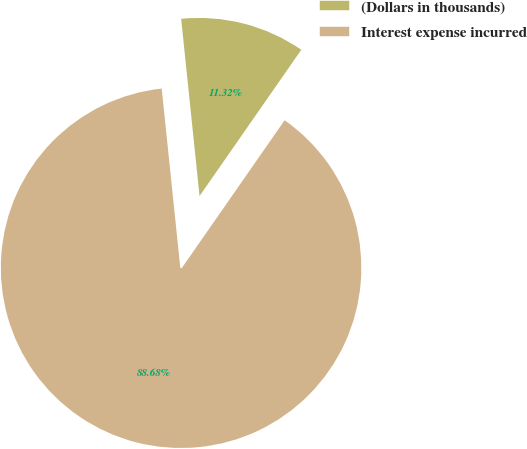Convert chart. <chart><loc_0><loc_0><loc_500><loc_500><pie_chart><fcel>(Dollars in thousands)<fcel>Interest expense incurred<nl><fcel>11.32%<fcel>88.68%<nl></chart> 